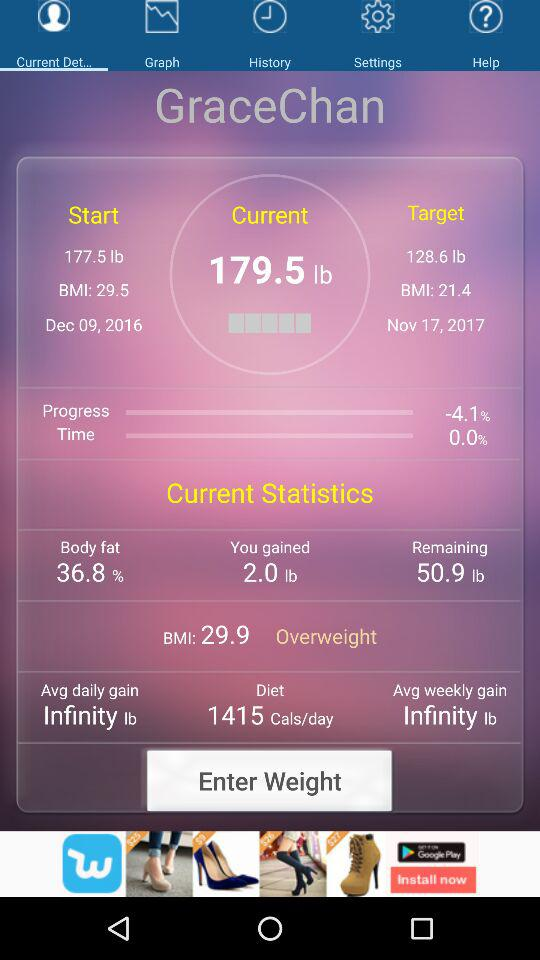What is the BMI of GraceChan?
Answer the question using a single word or phrase. 29.9 